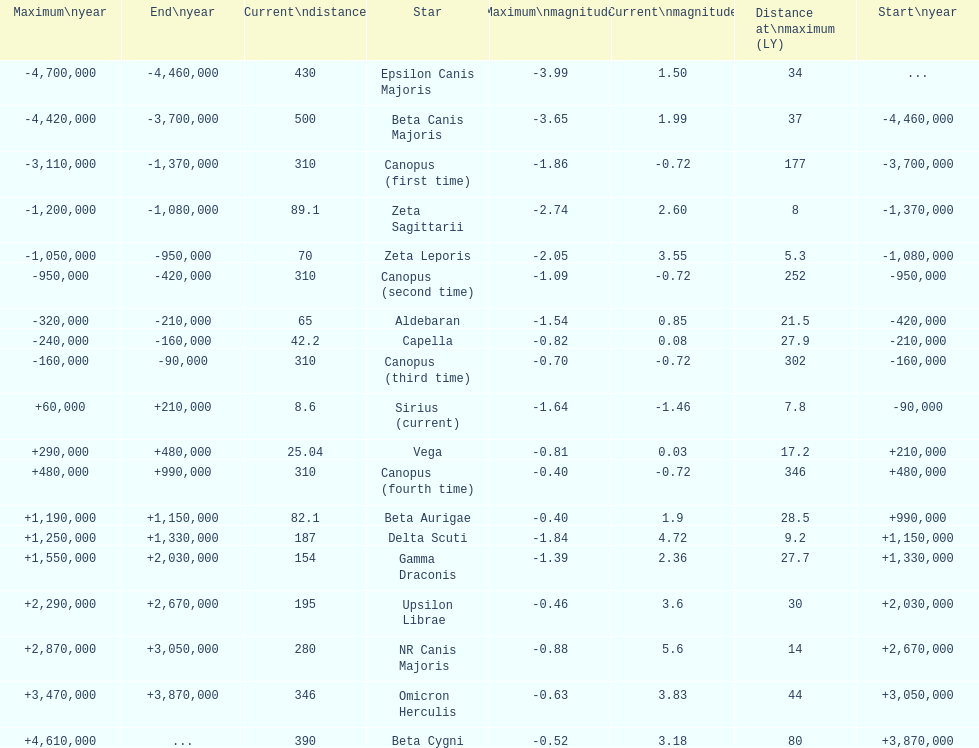How many stars have a distance at maximum of 30 light years or higher? 9. 